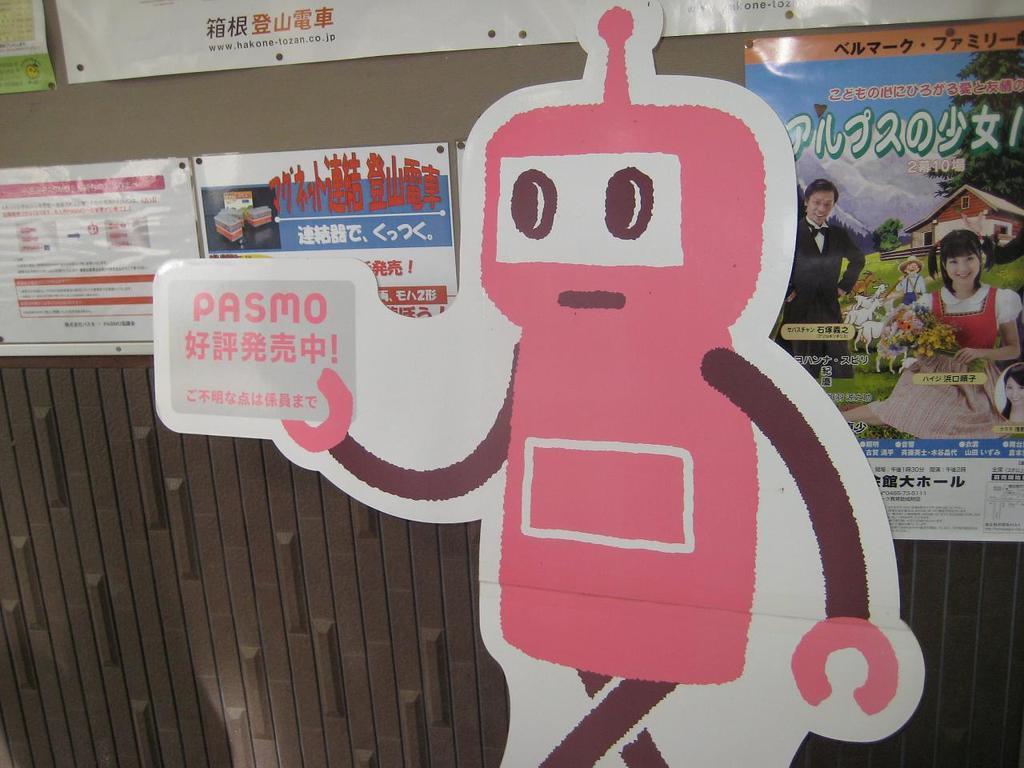Can you describe this image briefly? In this image there is a wall and we can see posters pasted on the wall. 